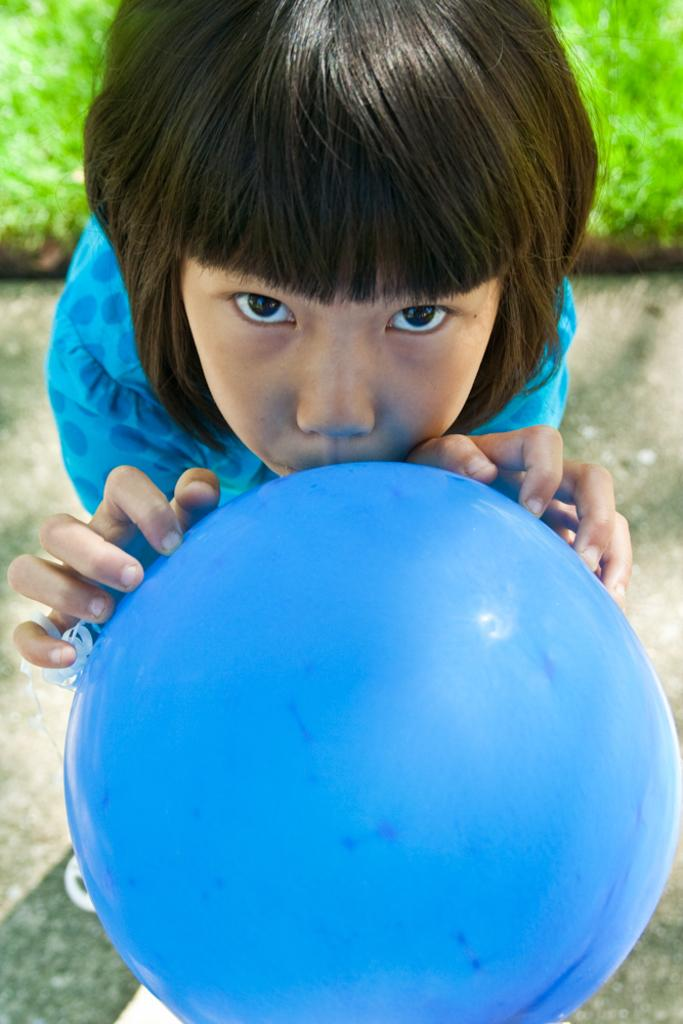What is the person in the image doing? The person is standing on the ground and holding a ball. What can be seen in the background of the image? Grass is visible in the background of the image. What type of pest can be seen crawling on the person's arm in the image? There is no pest visible on the person's arm in the image. 